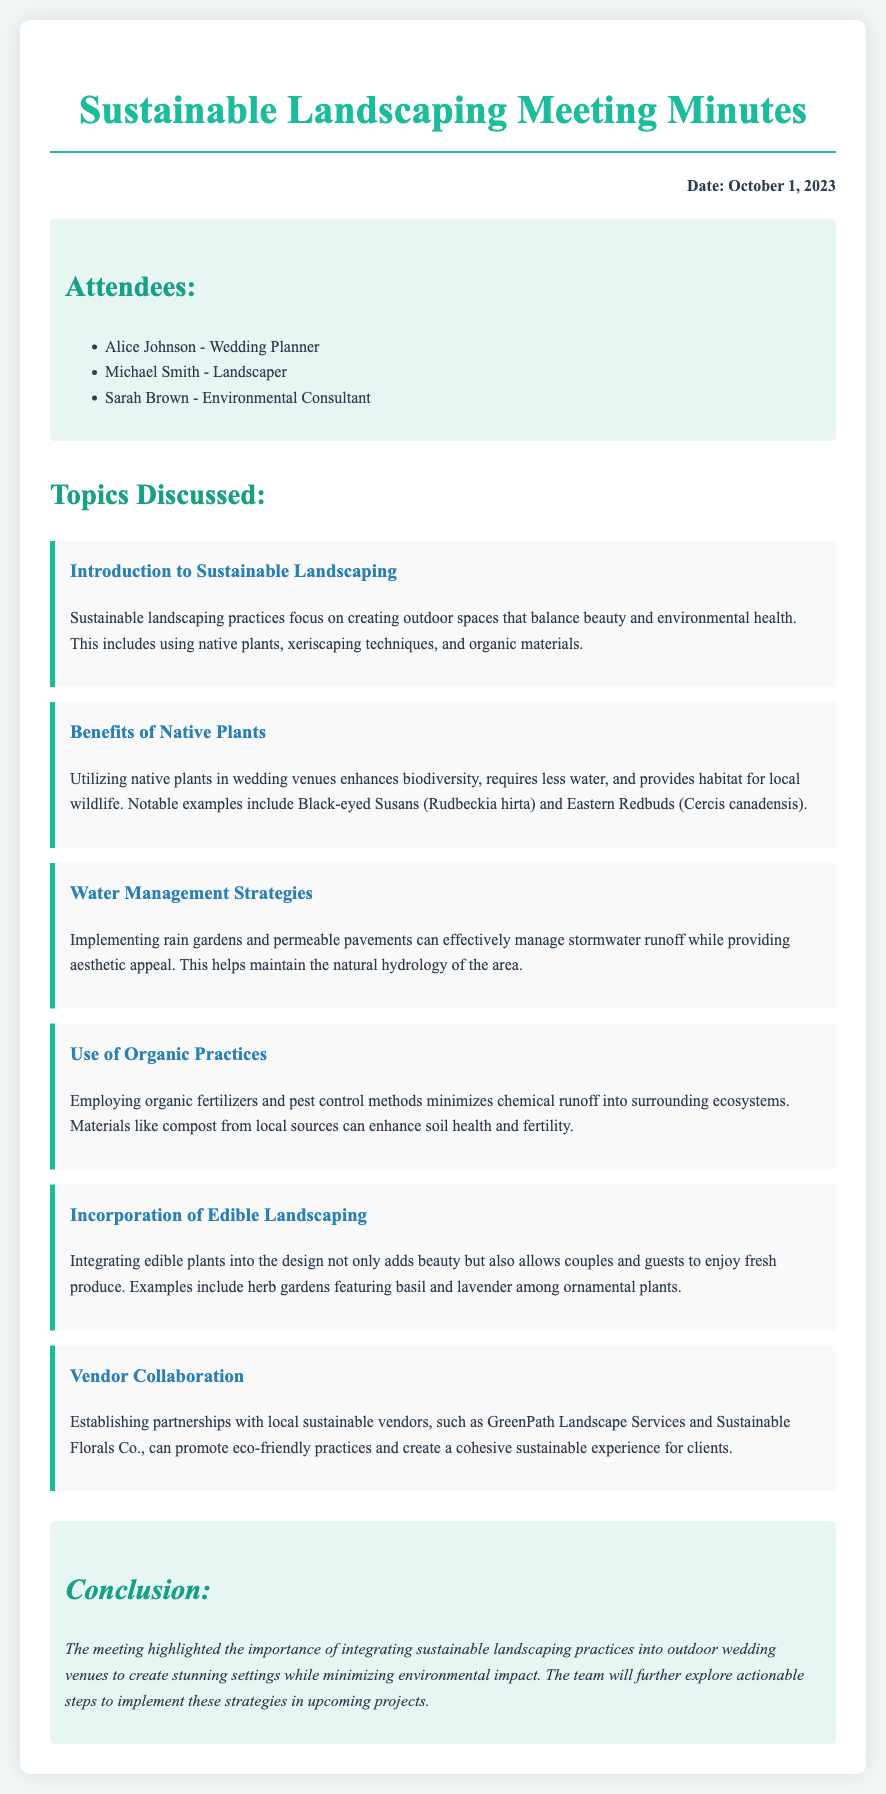what is the date of the meeting? The date of the meeting is explicitly mentioned at the top of the document.
Answer: October 1, 2023 who is the wedding planner present at the meeting? The attendees section lists the names and roles of individuals present, including the wedding planner.
Answer: Alice Johnson what type of plants are suggested for enhancing biodiversity? The benefits of native plants section discusses the advantages of using specific types of plants.
Answer: Native plants what is one water management strategy mentioned? Several strategies are outlined for managing water, one of which is directly mentioned.
Answer: Rain gardens what are the two examples of edible plants given? The incorporation of edible landscaping section provides specific examples of plants that can be integrated.
Answer: Basil and lavender which local vendor was mentioned as a sustainable option? The vendor collaboration section lists partnerships with specific sustainable vendors.
Answer: GreenPath Landscape Services what main subject does the introduction focus on? The introduction outlines the overarching theme of the meeting discussion.
Answer: Sustainable landscaping what is noted as a benefit of using organic practices? The use of organic practices section discusses the advantages regarding chemical use.
Answer: Minimizes chemical runoff 